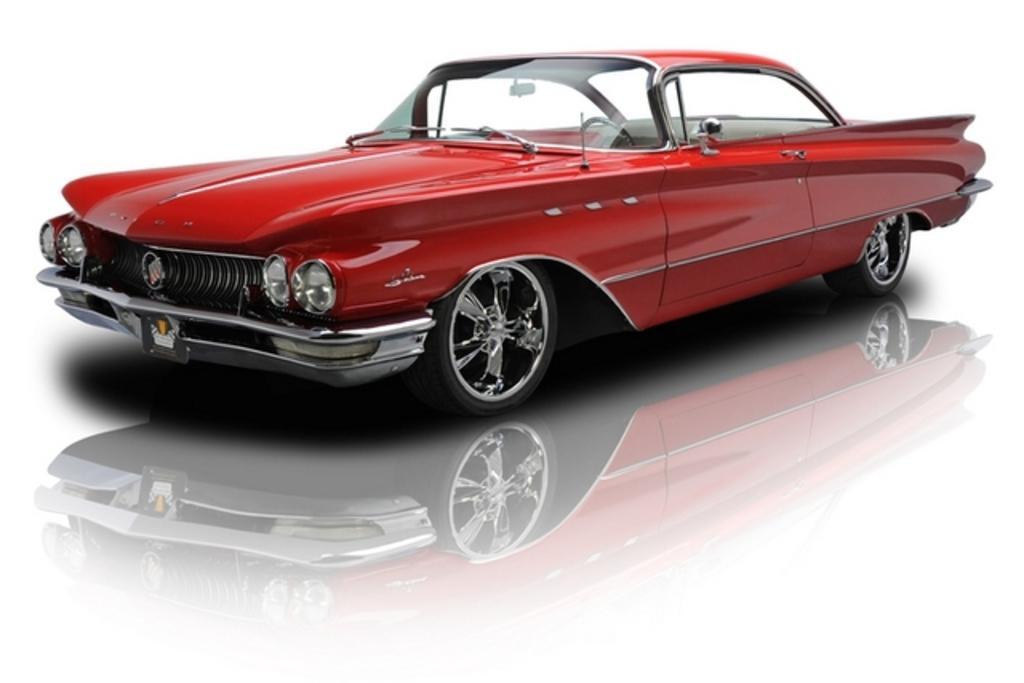Could you give a brief overview of what you see in this image? In the given image I can see a car on the white surface. 